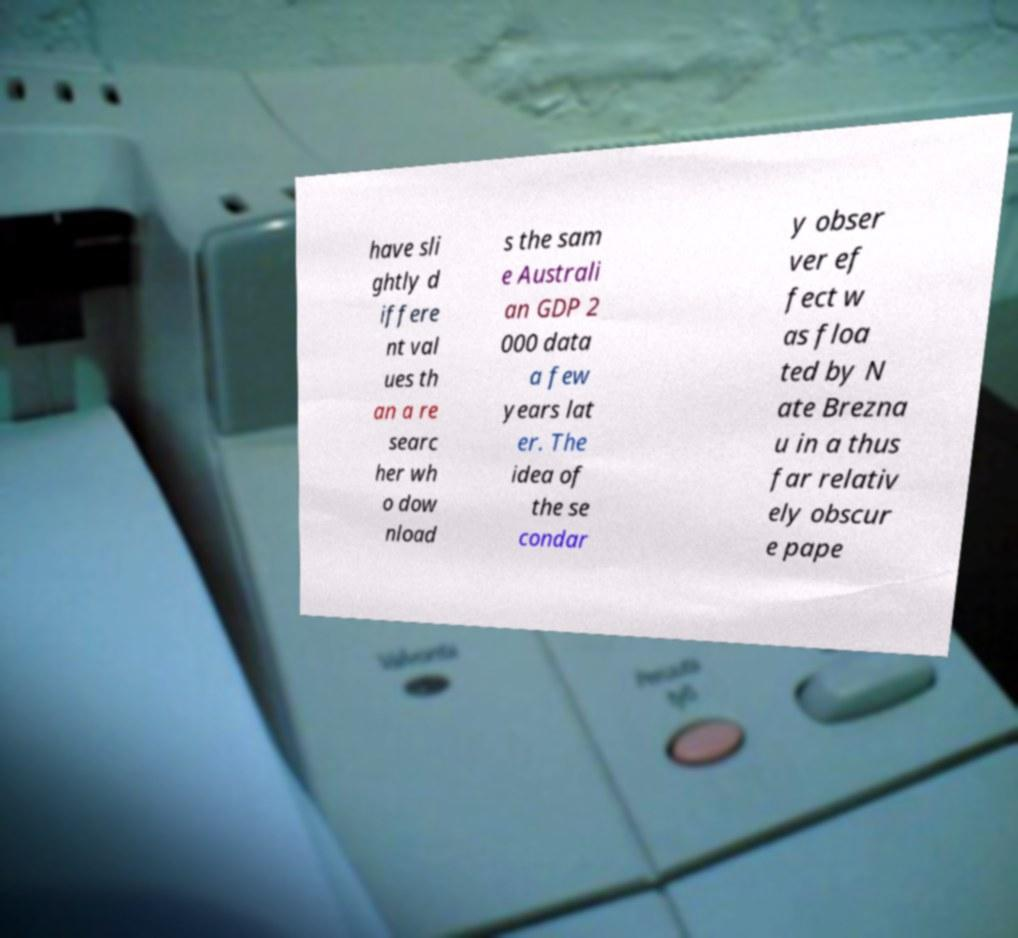There's text embedded in this image that I need extracted. Can you transcribe it verbatim? have sli ghtly d iffere nt val ues th an a re searc her wh o dow nload s the sam e Australi an GDP 2 000 data a few years lat er. The idea of the se condar y obser ver ef fect w as floa ted by N ate Brezna u in a thus far relativ ely obscur e pape 